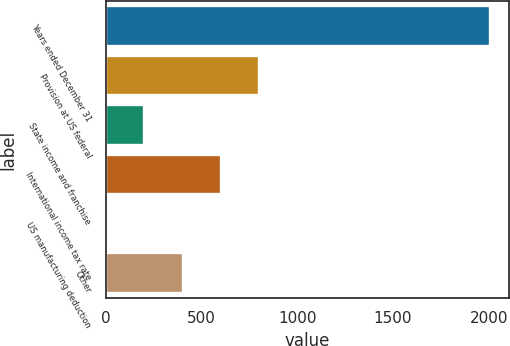<chart> <loc_0><loc_0><loc_500><loc_500><bar_chart><fcel>Years ended December 31<fcel>Provision at US federal<fcel>State income and franchise<fcel>International income tax rate<fcel>US manufacturing deduction<fcel>Other<nl><fcel>2007<fcel>803.1<fcel>201.15<fcel>602.45<fcel>0.5<fcel>401.8<nl></chart> 